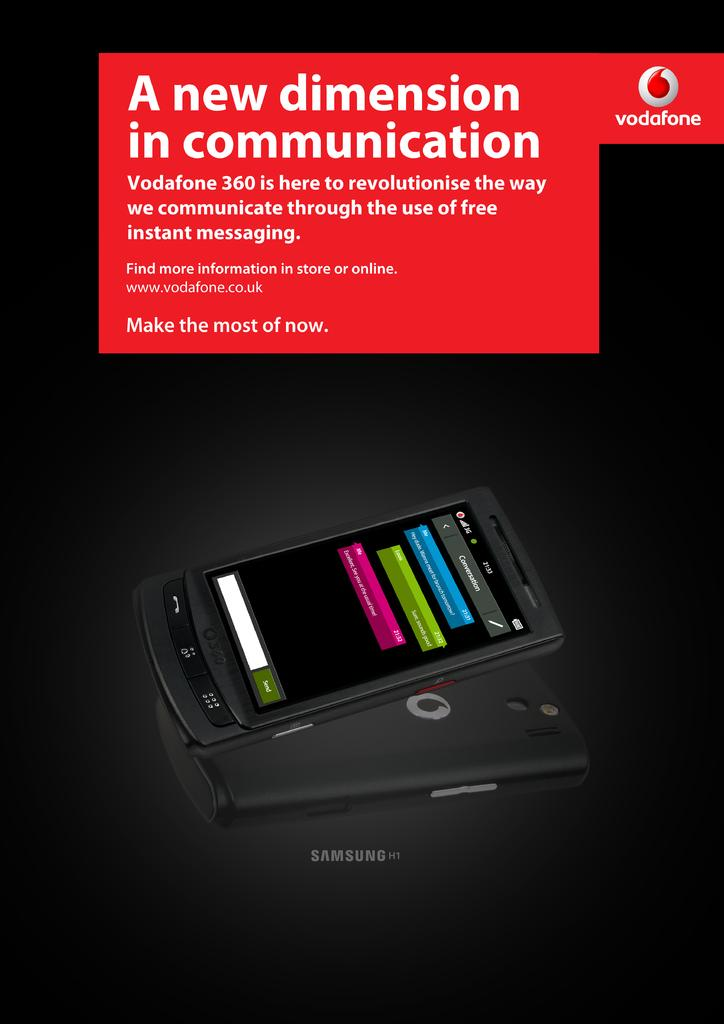<image>
Give a short and clear explanation of the subsequent image. An advertisement for Vodafone communication via instant messaging. 